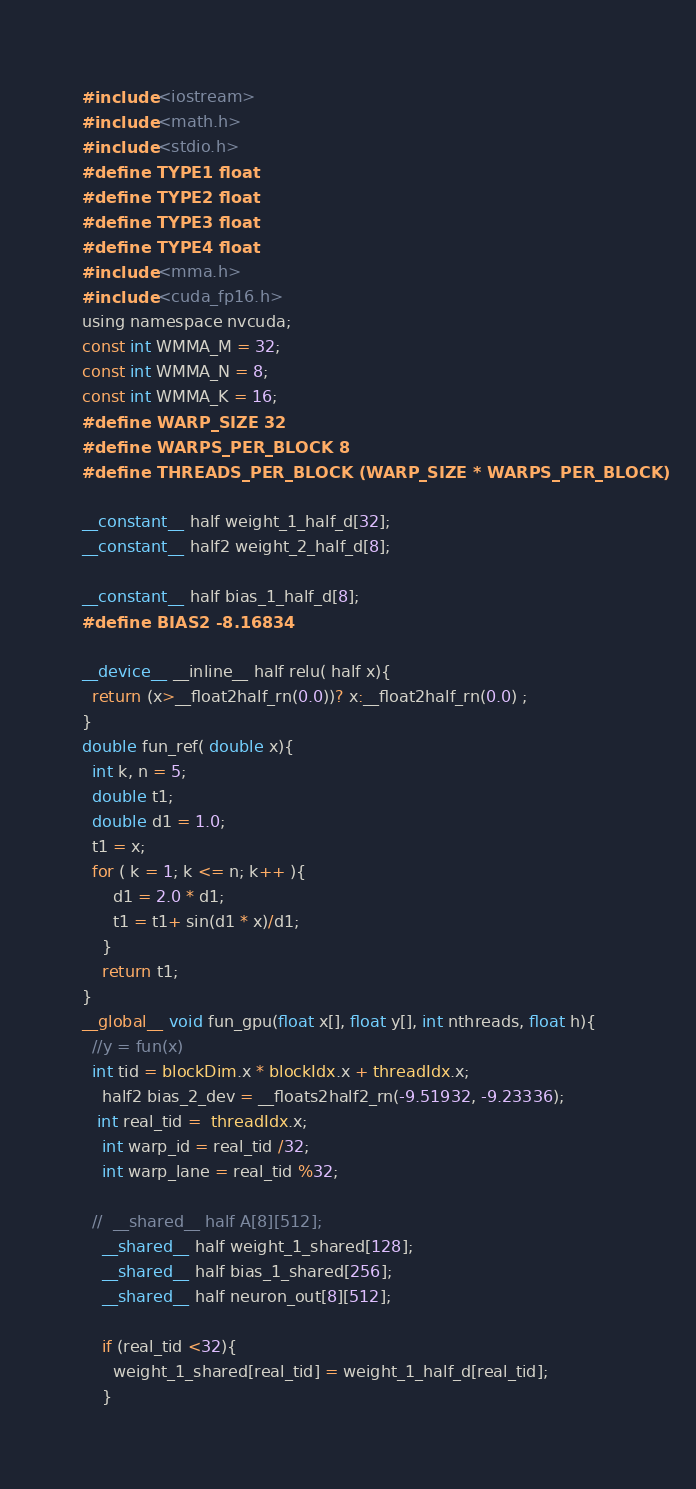<code> <loc_0><loc_0><loc_500><loc_500><_Cuda_>#include <iostream>
#include <math.h>
#include <stdio.h>
#define TYPE1 float
#define TYPE2 float
#define TYPE3 float
#define TYPE4 float
#include <mma.h>
#include <cuda_fp16.h>
using namespace nvcuda;
const int WMMA_M = 32;
const int WMMA_N = 8;
const int WMMA_K = 16;
#define WARP_SIZE 32
#define WARPS_PER_BLOCK 8
#define THREADS_PER_BLOCK (WARP_SIZE * WARPS_PER_BLOCK)

__constant__ half weight_1_half_d[32];
__constant__ half2 weight_2_half_d[8];

__constant__ half bias_1_half_d[8];
#define BIAS2 -8.16834

__device__ __inline__ half relu( half x){
  return (x>__float2half_rn(0.0))? x:__float2half_rn(0.0) ;
}
double fun_ref( double x){
  int k, n = 5;
  double t1;
  double d1 = 1.0;
  t1 = x;
  for ( k = 1; k <= n; k++ ){
      d1 = 2.0 * d1;
      t1 = t1+ sin(d1 * x)/d1;
    }
    return t1;
}
__global__ void fun_gpu(float x[], float y[], int nthreads, float h){
  //y = fun(x)
  int tid = blockDim.x * blockIdx.x + threadIdx.x;
	half2 bias_2_dev = __floats2half2_rn(-9.51932, -9.23336);
   int real_tid =  threadIdx.x;
    int warp_id = real_tid /32;
    int warp_lane = real_tid %32;

  //  __shared__ half A[8][512];
    __shared__ half weight_1_shared[128];
    __shared__ half bias_1_shared[256];
    __shared__ half neuron_out[8][512];
 
    if (real_tid <32){
      weight_1_shared[real_tid] = weight_1_half_d[real_tid];
    }</code> 